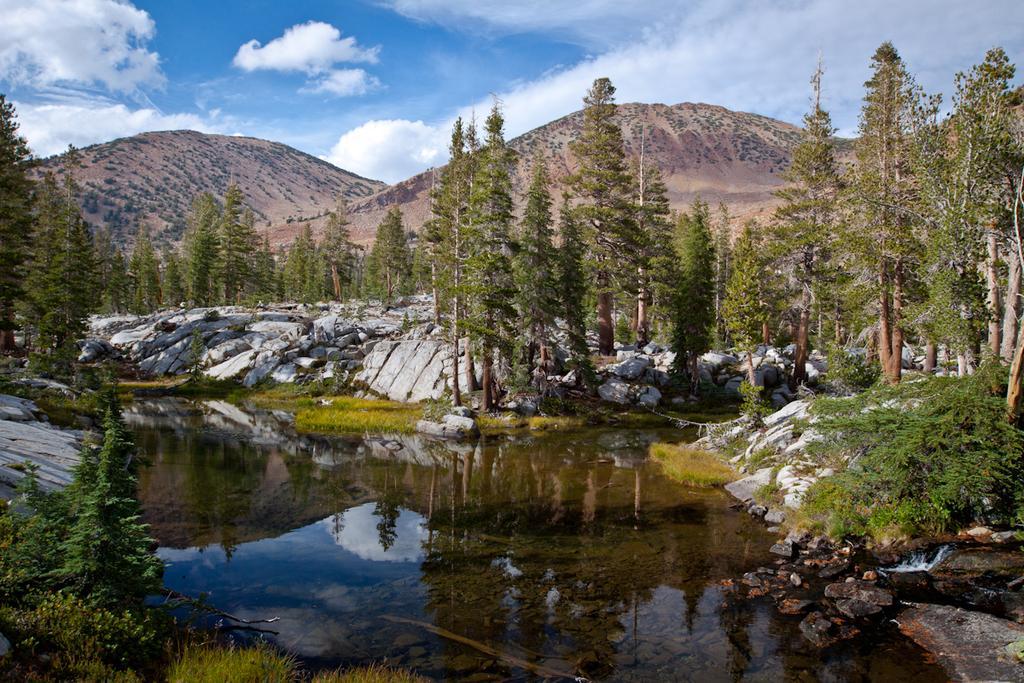How would you summarize this image in a sentence or two? This image is taken outdoors. At the top of the image there is a sky with clouds. At the bottom of the image there is a pond with water and there is a ground with many rocks and grass on it and there are a few plants and many trees. In the background there are a few hills. 